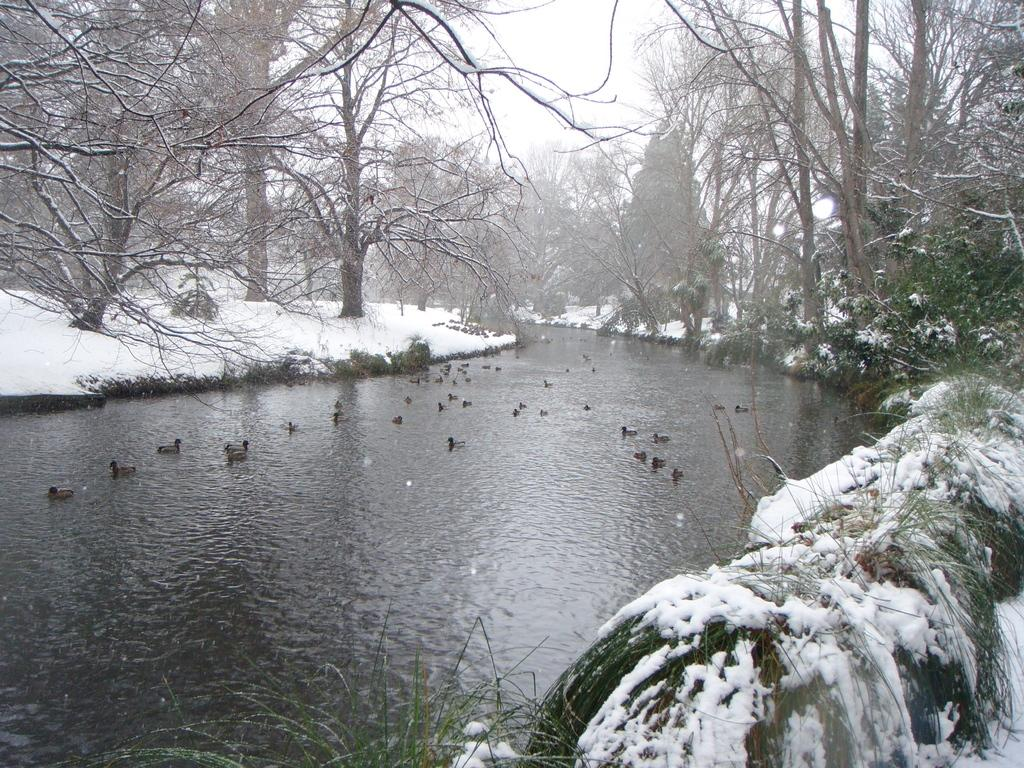What type of water body is visible in the image? There is a canal in the image. What animals can be seen in the canal? There are ducks in the canal. How is the land around the canal affected by the weather? The land on either side of the canal is covered with snow. What type of vegetation is near the canal? There are trees present near the canal. What type of linen is draped over the throne in the image? There is no linen or throne present in the image; it features a canal with ducks and snow-covered land. 